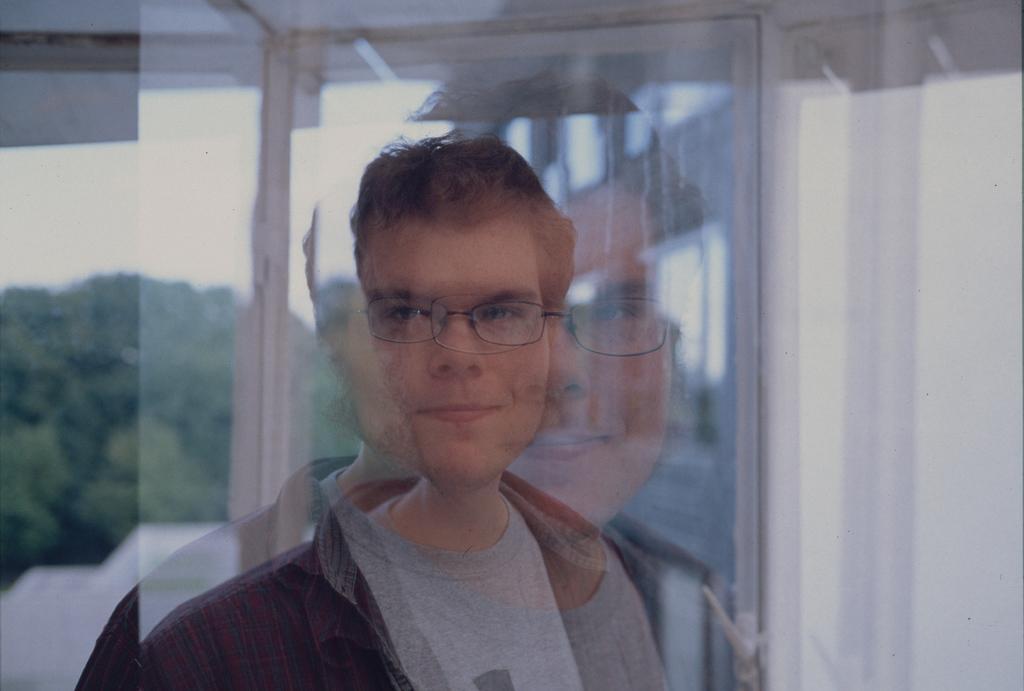Could you give a brief overview of what you see in this image? In this image we can see a man. In the background there are trees, sky and walls. 